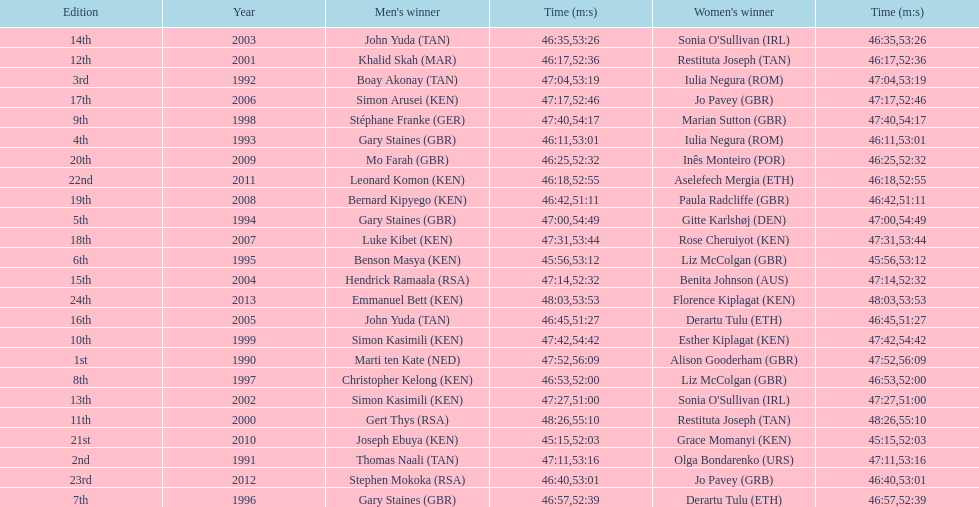Can you give me this table as a dict? {'header': ['Edition', 'Year', "Men's winner", 'Time (m:s)', "Women's winner", 'Time (m:s)'], 'rows': [['14th', '2003', 'John Yuda\xa0(TAN)', '46:35', "Sonia O'Sullivan\xa0(IRL)", '53:26'], ['12th', '2001', 'Khalid Skah\xa0(MAR)', '46:17', 'Restituta Joseph\xa0(TAN)', '52:36'], ['3rd', '1992', 'Boay Akonay\xa0(TAN)', '47:04', 'Iulia Negura\xa0(ROM)', '53:19'], ['17th', '2006', 'Simon Arusei\xa0(KEN)', '47:17', 'Jo Pavey\xa0(GBR)', '52:46'], ['9th', '1998', 'Stéphane Franke\xa0(GER)', '47:40', 'Marian Sutton\xa0(GBR)', '54:17'], ['4th', '1993', 'Gary Staines\xa0(GBR)', '46:11', 'Iulia Negura\xa0(ROM)', '53:01'], ['20th', '2009', 'Mo Farah\xa0(GBR)', '46:25', 'Inês Monteiro\xa0(POR)', '52:32'], ['22nd', '2011', 'Leonard Komon\xa0(KEN)', '46:18', 'Aselefech Mergia\xa0(ETH)', '52:55'], ['19th', '2008', 'Bernard Kipyego\xa0(KEN)', '46:42', 'Paula Radcliffe\xa0(GBR)', '51:11'], ['5th', '1994', 'Gary Staines\xa0(GBR)', '47:00', 'Gitte Karlshøj\xa0(DEN)', '54:49'], ['18th', '2007', 'Luke Kibet\xa0(KEN)', '47:31', 'Rose Cheruiyot\xa0(KEN)', '53:44'], ['6th', '1995', 'Benson Masya\xa0(KEN)', '45:56', 'Liz McColgan\xa0(GBR)', '53:12'], ['15th', '2004', 'Hendrick Ramaala\xa0(RSA)', '47:14', 'Benita Johnson\xa0(AUS)', '52:32'], ['24th', '2013', 'Emmanuel Bett\xa0(KEN)', '48:03', 'Florence Kiplagat\xa0(KEN)', '53:53'], ['16th', '2005', 'John Yuda\xa0(TAN)', '46:45', 'Derartu Tulu\xa0(ETH)', '51:27'], ['10th', '1999', 'Simon Kasimili\xa0(KEN)', '47:42', 'Esther Kiplagat\xa0(KEN)', '54:42'], ['1st', '1990', 'Marti ten Kate\xa0(NED)', '47:52', 'Alison Gooderham\xa0(GBR)', '56:09'], ['8th', '1997', 'Christopher Kelong\xa0(KEN)', '46:53', 'Liz McColgan\xa0(GBR)', '52:00'], ['13th', '2002', 'Simon Kasimili\xa0(KEN)', '47:27', "Sonia O'Sullivan\xa0(IRL)", '51:00'], ['11th', '2000', 'Gert Thys\xa0(RSA)', '48:26', 'Restituta Joseph\xa0(TAN)', '55:10'], ['21st', '2010', 'Joseph Ebuya\xa0(KEN)', '45:15', 'Grace Momanyi\xa0(KEN)', '52:03'], ['2nd', '1991', 'Thomas Naali\xa0(TAN)', '47:11', 'Olga Bondarenko\xa0(URS)', '53:16'], ['23rd', '2012', 'Stephen Mokoka\xa0(RSA)', '46:40', 'Jo Pavey\xa0(GRB)', '53:01'], ['7th', '1996', 'Gary Staines\xa0(GBR)', '46:57', 'Derartu Tulu\xa0(ETH)', '52:39']]} Who is the male winner listed before gert thys? Simon Kasimili. 